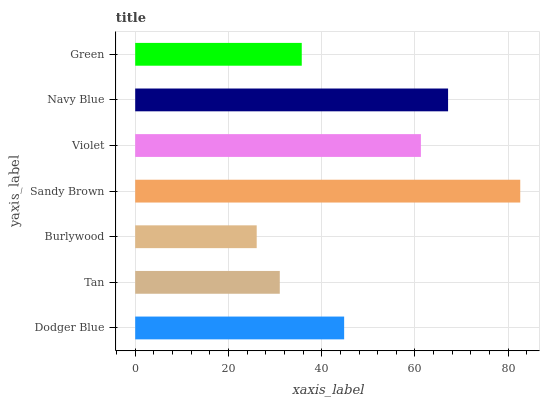Is Burlywood the minimum?
Answer yes or no. Yes. Is Sandy Brown the maximum?
Answer yes or no. Yes. Is Tan the minimum?
Answer yes or no. No. Is Tan the maximum?
Answer yes or no. No. Is Dodger Blue greater than Tan?
Answer yes or no. Yes. Is Tan less than Dodger Blue?
Answer yes or no. Yes. Is Tan greater than Dodger Blue?
Answer yes or no. No. Is Dodger Blue less than Tan?
Answer yes or no. No. Is Dodger Blue the high median?
Answer yes or no. Yes. Is Dodger Blue the low median?
Answer yes or no. Yes. Is Burlywood the high median?
Answer yes or no. No. Is Violet the low median?
Answer yes or no. No. 